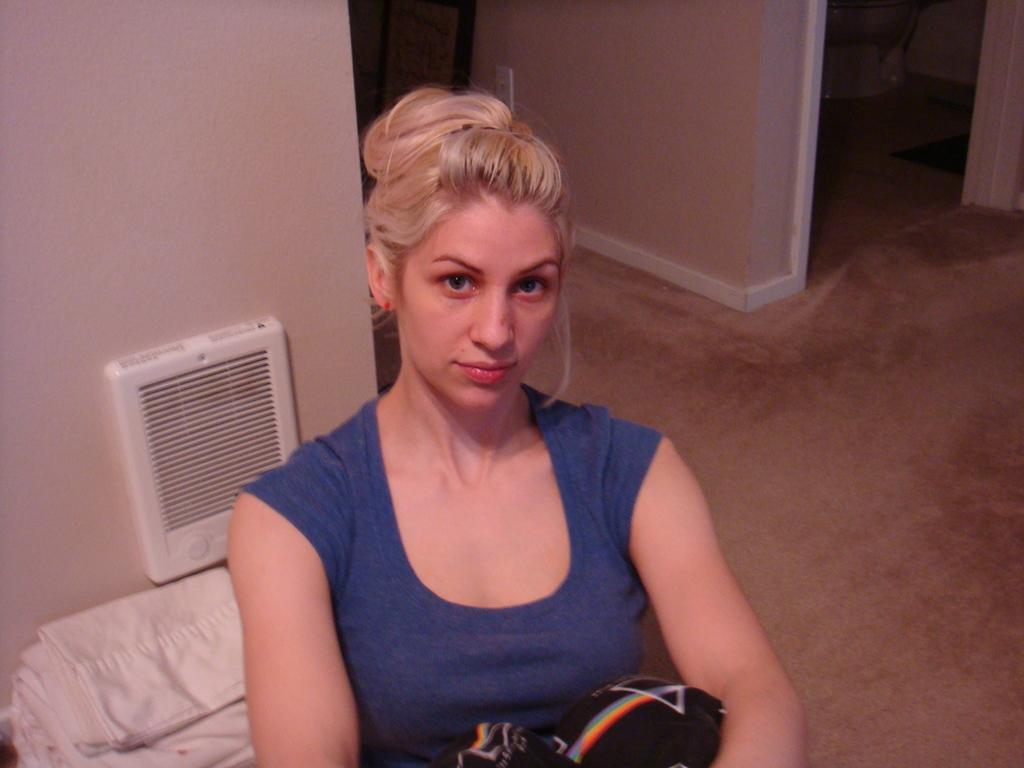Who is present in the image? There is a woman in the image. What is the woman wearing? The woman is wearing a blue t-shirt. What can be seen behind the woman? There are white clothes visible behind the woman. What is the setting of the image? There are walls in the background of the image, and the image shows a floor. What type of ink is being used by the government in the image? There is no reference to ink or the government in the image, so it is not possible to answer that question. 